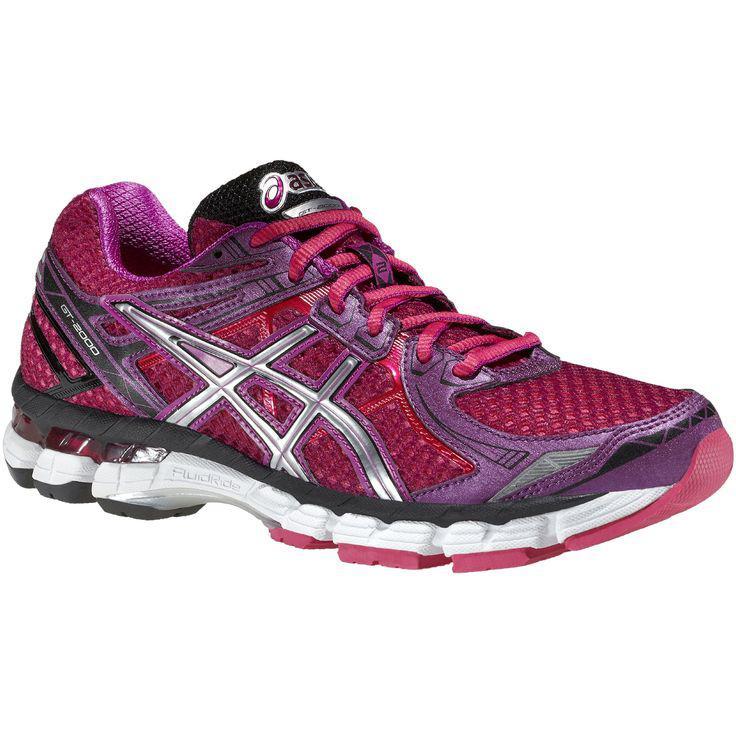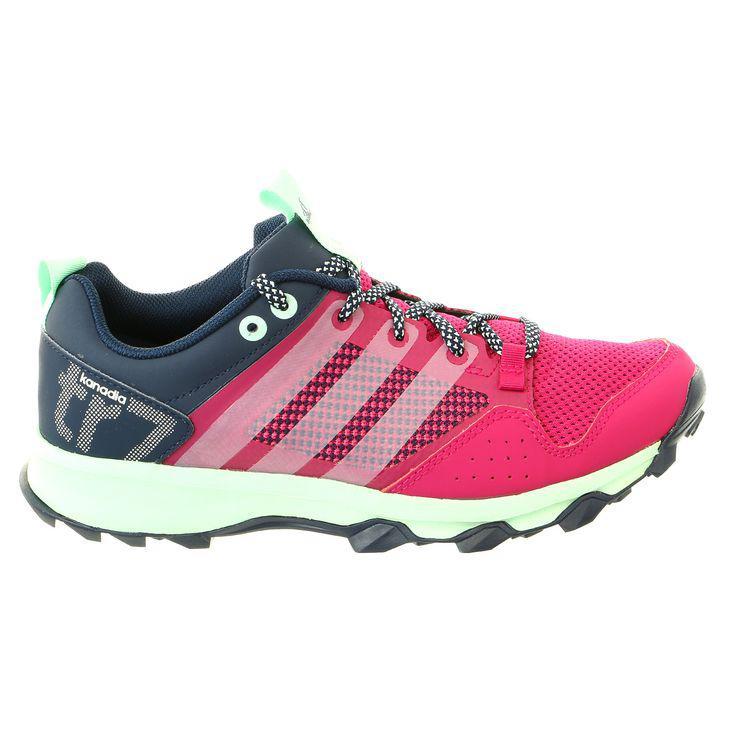The first image is the image on the left, the second image is the image on the right. Evaluate the accuracy of this statement regarding the images: "The images show a total of two sneakers, both facing right.". Is it true? Answer yes or no. Yes. 